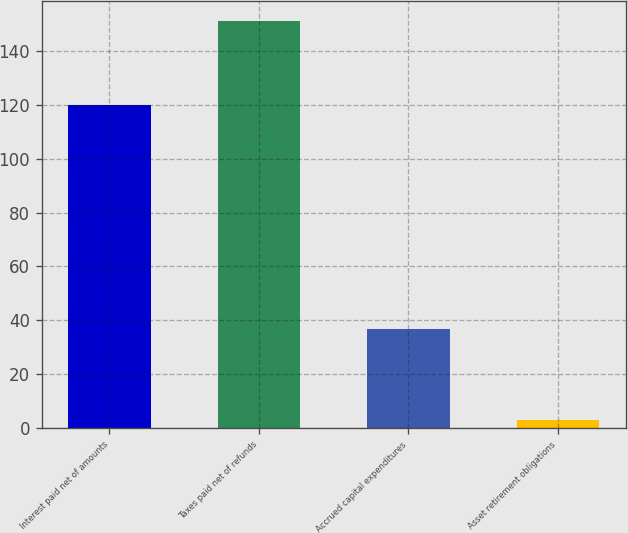Convert chart to OTSL. <chart><loc_0><loc_0><loc_500><loc_500><bar_chart><fcel>Interest paid net of amounts<fcel>Taxes paid net of refunds<fcel>Accrued capital expenditures<fcel>Asset retirement obligations<nl><fcel>120<fcel>151<fcel>37<fcel>3<nl></chart> 